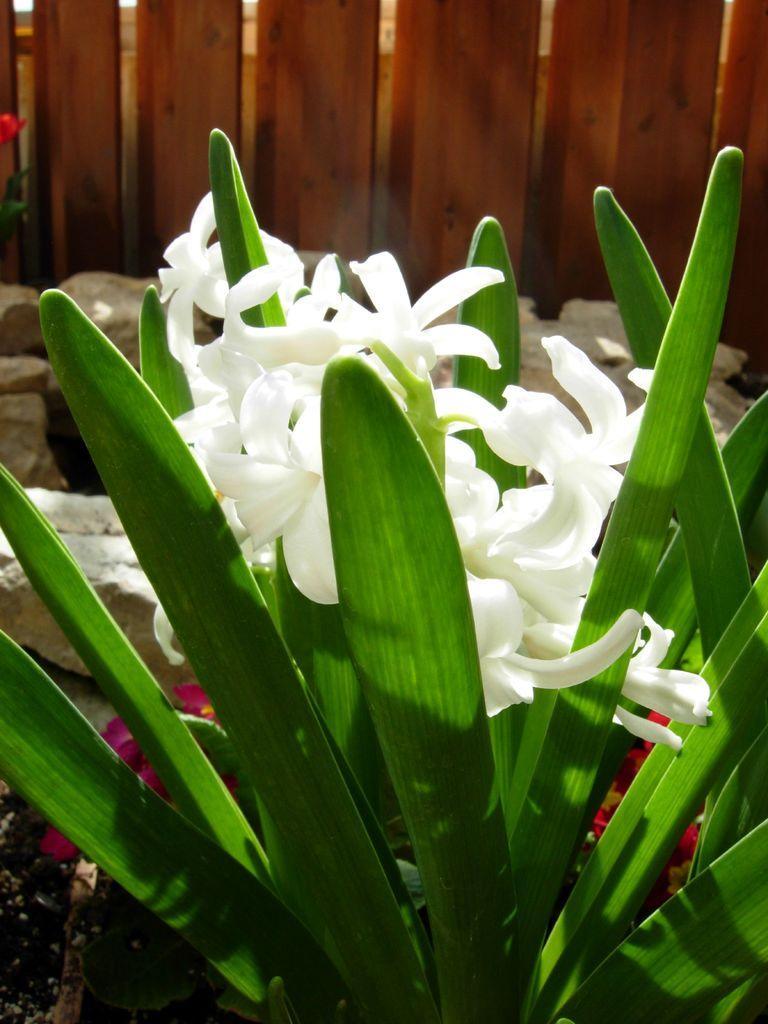Describe this image in one or two sentences. In this picture we can see a plant with white flowers and behind the plant there are rocks and a wooden fence. 